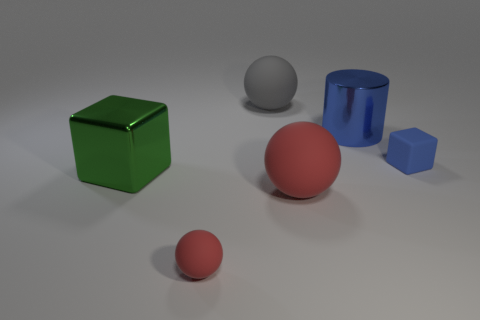There is a red thing right of the big gray sphere; what is its shape?
Your answer should be compact. Sphere. Does the cube left of the tiny matte block have the same material as the red sphere on the right side of the tiny red rubber thing?
Make the answer very short. No. Are there any big green rubber objects that have the same shape as the large red object?
Your answer should be very brief. No. How many objects are either blue objects to the left of the blue block or tiny matte balls?
Ensure brevity in your answer.  2. Are there more gray spheres that are on the right side of the large cylinder than red rubber spheres that are behind the big red matte thing?
Your answer should be very brief. No. How many shiny objects are tiny blue things or blue objects?
Provide a short and direct response. 1. There is a object that is the same color as the big metal cylinder; what material is it?
Give a very brief answer. Rubber. Are there fewer rubber cubes that are left of the gray object than blue blocks on the left side of the green shiny object?
Your answer should be compact. No. How many things are either small blue matte things or balls that are in front of the large gray sphere?
Make the answer very short. 3. There is a gray thing that is the same size as the blue cylinder; what material is it?
Provide a short and direct response. Rubber. 